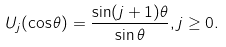Convert formula to latex. <formula><loc_0><loc_0><loc_500><loc_500>U _ { j } ( \cos \theta ) = \frac { \sin ( j + 1 ) \theta } { \sin \theta } , j \geq 0 .</formula> 